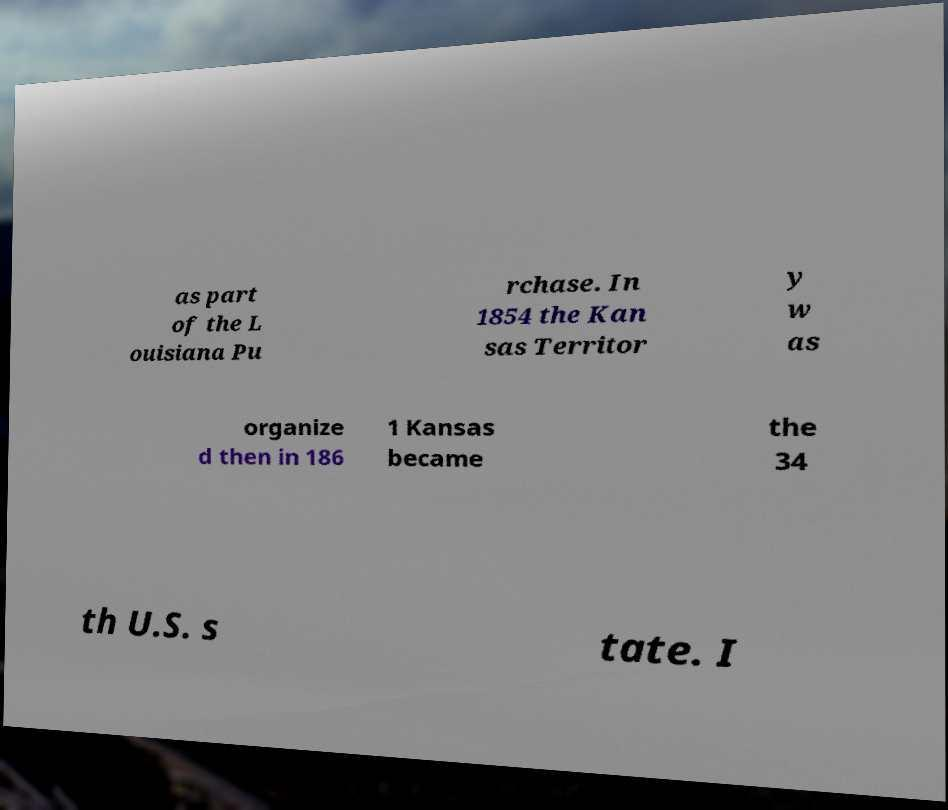Can you read and provide the text displayed in the image?This photo seems to have some interesting text. Can you extract and type it out for me? as part of the L ouisiana Pu rchase. In 1854 the Kan sas Territor y w as organize d then in 186 1 Kansas became the 34 th U.S. s tate. I 